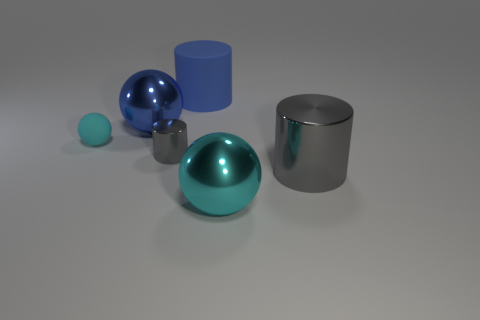There is a big metallic thing that is the same color as the rubber ball; what shape is it?
Provide a short and direct response. Sphere. What material is the other cylinder that is the same color as the small metallic cylinder?
Give a very brief answer. Metal. There is a big cyan thing; are there any large metallic things behind it?
Make the answer very short. Yes. Is there another big thing that has the same shape as the big gray thing?
Provide a succinct answer. Yes. There is a big blue thing in front of the big matte cylinder; is its shape the same as the cyan object on the right side of the big blue cylinder?
Ensure brevity in your answer.  Yes. Is there a green matte block of the same size as the matte cylinder?
Offer a terse response. No. Are there the same number of shiny objects that are in front of the large cyan metallic thing and rubber objects that are in front of the small rubber object?
Provide a succinct answer. Yes. Does the thing that is to the left of the blue shiny ball have the same material as the large cylinder that is in front of the tiny gray cylinder?
Keep it short and to the point. No. What is the small cyan ball made of?
Provide a short and direct response. Rubber. What number of other objects are the same color as the matte ball?
Make the answer very short. 1. 